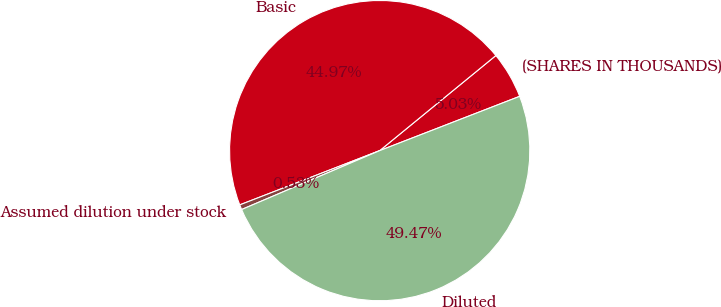Convert chart. <chart><loc_0><loc_0><loc_500><loc_500><pie_chart><fcel>(SHARES IN THOUSANDS)<fcel>Basic<fcel>Assumed dilution under stock<fcel>Diluted<nl><fcel>5.03%<fcel>44.97%<fcel>0.53%<fcel>49.47%<nl></chart> 